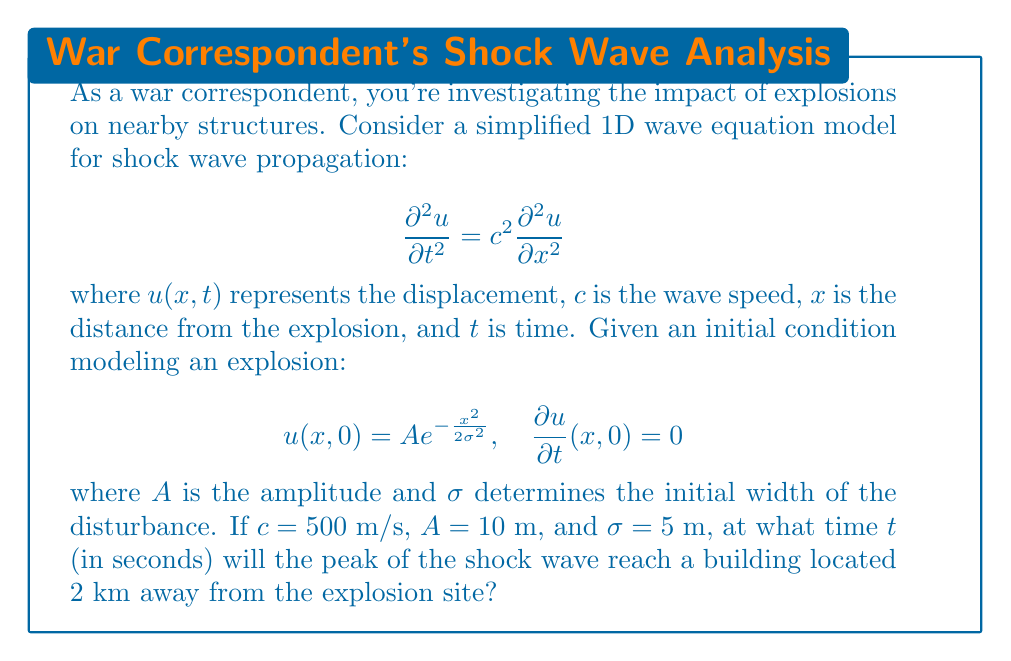Give your solution to this math problem. To solve this problem, we need to understand how the initial disturbance propagates according to the wave equation. The solution to this 1D wave equation with the given initial conditions is:

$$u(x,t) = \frac{A}{2}\left(e^{-\frac{(x-ct)^2}{2\sigma^2}} + e^{-\frac{(x+ct)^2}{2\sigma^2}}\right)$$

This solution represents two waves moving in opposite directions from the initial disturbance. We're interested in the wave moving in the positive x-direction.

The peak of the wave at any time $t$ is located at $x = ct$. To find when the peak reaches the building:

1) Set up the equation:
   $x = ct$

2) Substitute the known values:
   $2000 \text{ m} = 500 \text{ m/s} \cdot t$

3) Solve for $t$:
   $t = \frac{2000 \text{ m}}{500 \text{ m/s}} = 4 \text{ s}$

Therefore, the peak of the shock wave will reach the building 4 seconds after the explosion.
Answer: 4 seconds 